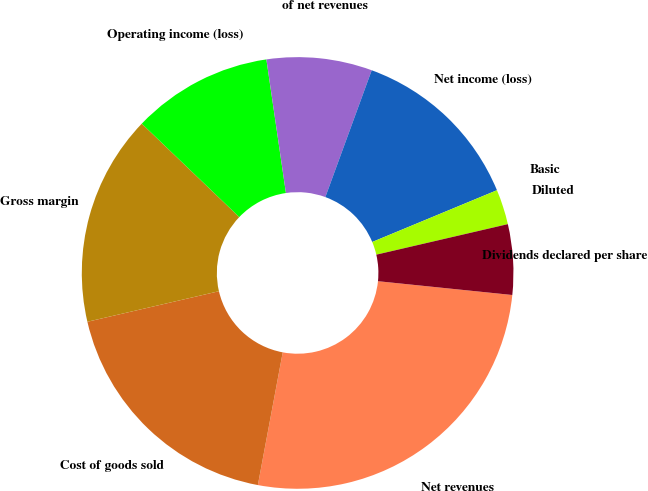Convert chart. <chart><loc_0><loc_0><loc_500><loc_500><pie_chart><fcel>Net revenues<fcel>Cost of goods sold<fcel>Gross margin<fcel>Operating income (loss)<fcel>of net revenues<fcel>Net income (loss)<fcel>Basic<fcel>Diluted<fcel>Dividends declared per share<nl><fcel>26.32%<fcel>18.42%<fcel>15.79%<fcel>10.53%<fcel>7.89%<fcel>13.16%<fcel>0.0%<fcel>2.63%<fcel>5.26%<nl></chart> 